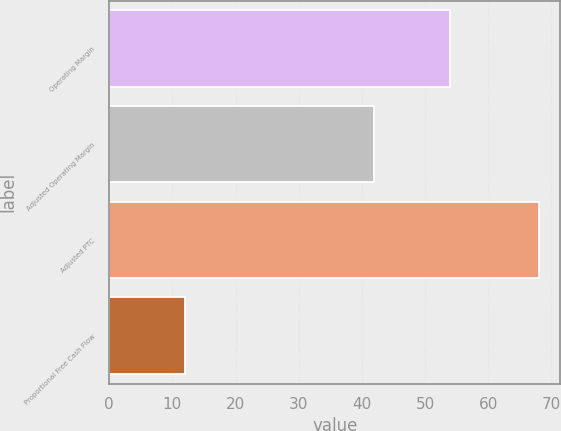<chart> <loc_0><loc_0><loc_500><loc_500><bar_chart><fcel>Operating Margin<fcel>Adjusted Operating Margin<fcel>Adjusted PTC<fcel>Proportional Free Cash Flow<nl><fcel>54<fcel>42<fcel>68<fcel>12<nl></chart> 